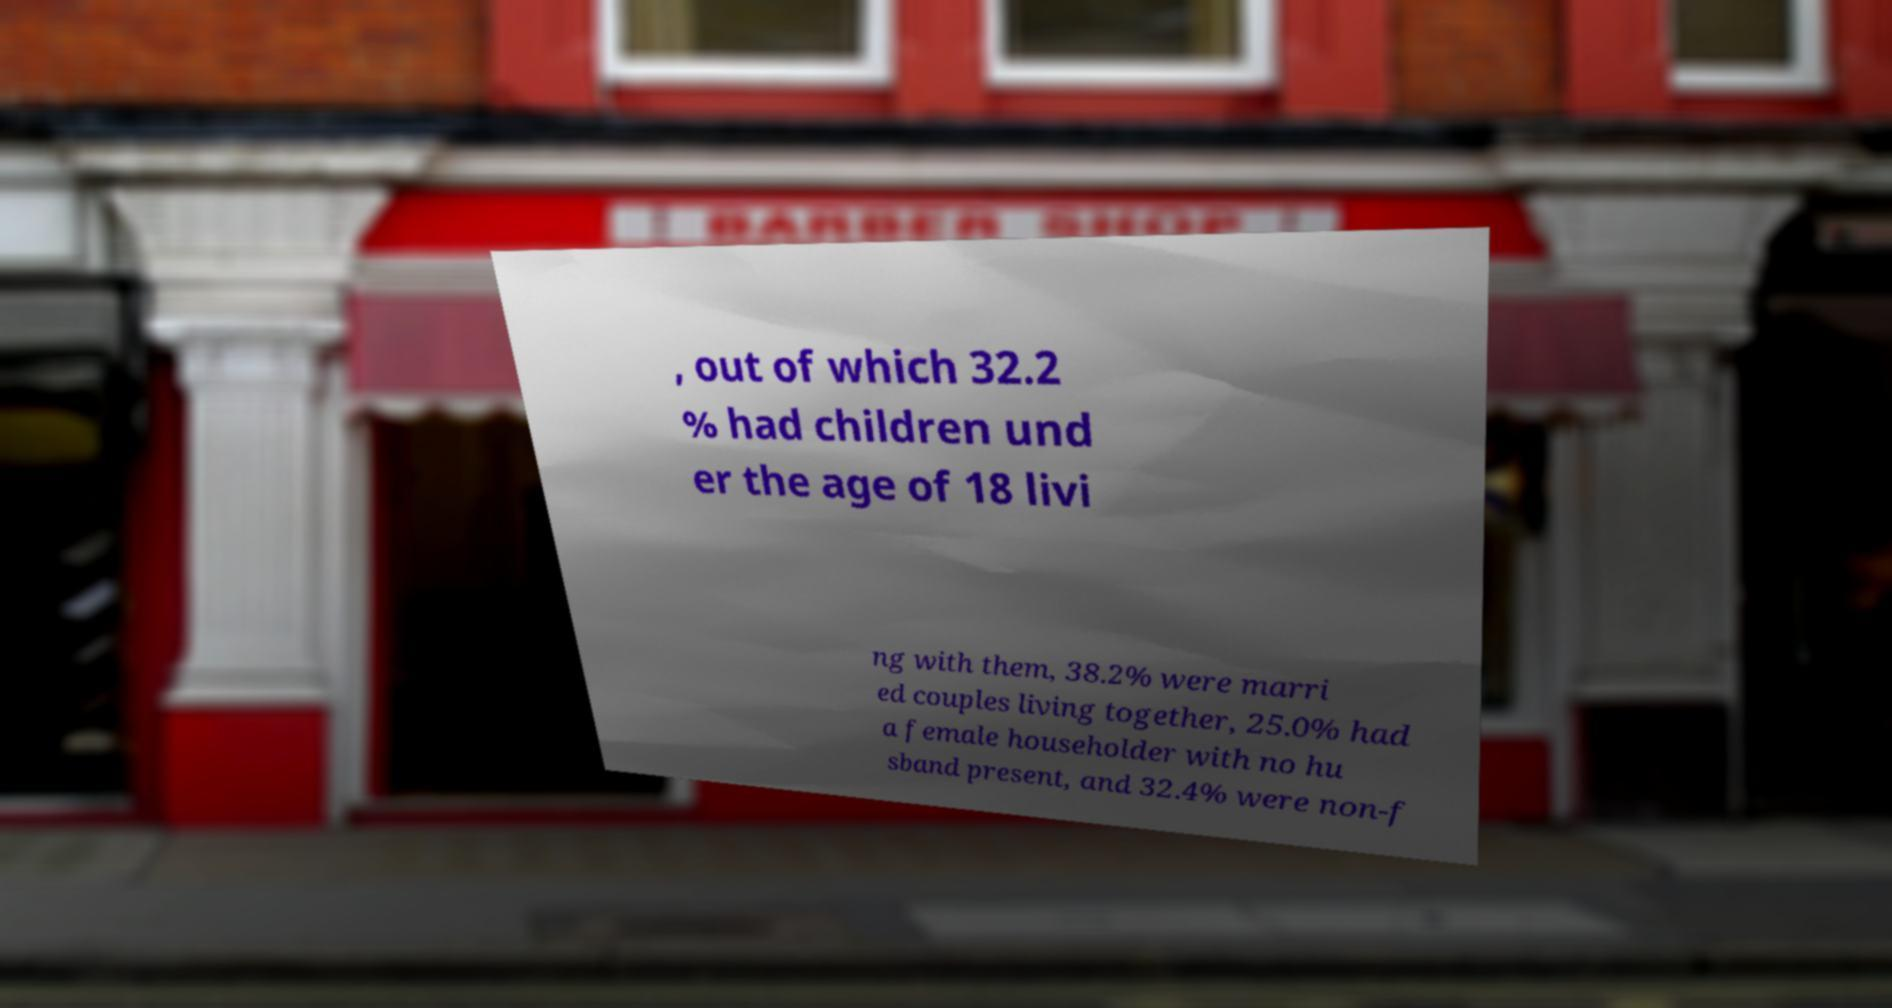Can you read and provide the text displayed in the image?This photo seems to have some interesting text. Can you extract and type it out for me? , out of which 32.2 % had children und er the age of 18 livi ng with them, 38.2% were marri ed couples living together, 25.0% had a female householder with no hu sband present, and 32.4% were non-f 